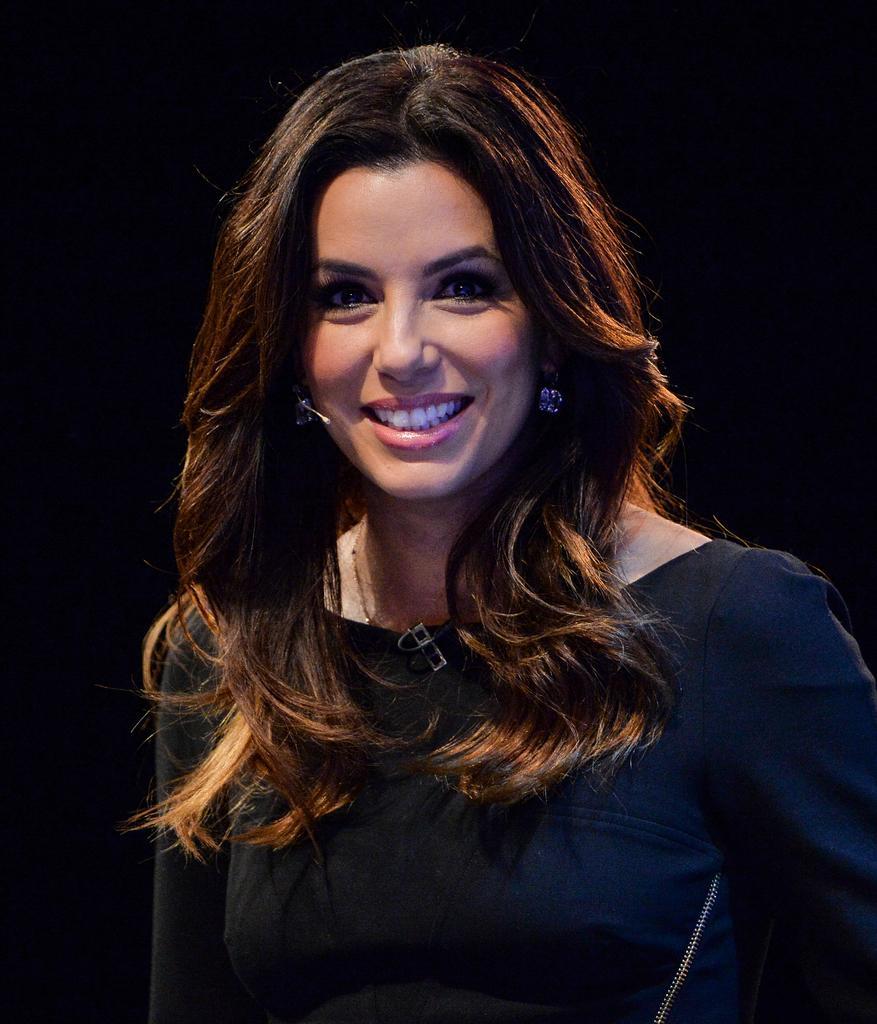Can you describe this image briefly? In this image we can see a woman. 